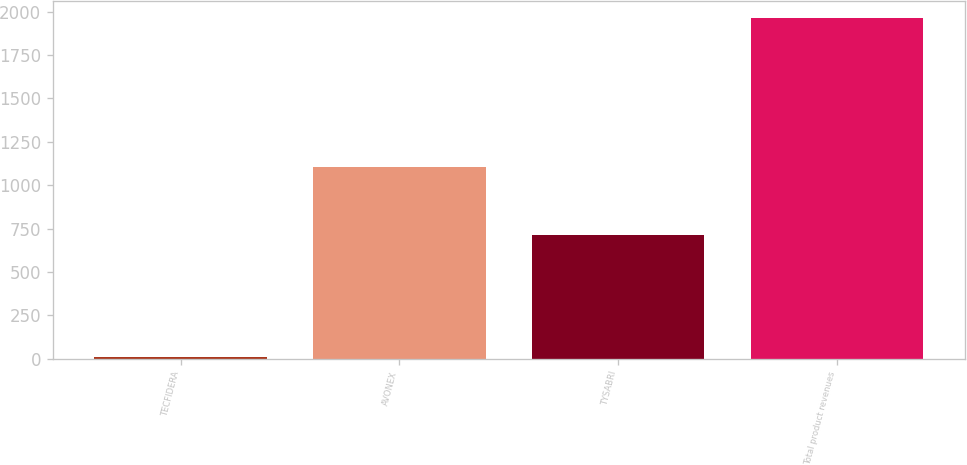Convert chart to OTSL. <chart><loc_0><loc_0><loc_500><loc_500><bar_chart><fcel>TECFIDERA<fcel>AVONEX<fcel>TYSABRI<fcel>Total product revenues<nl><fcel>11.7<fcel>1103.1<fcel>712.3<fcel>1961.3<nl></chart> 